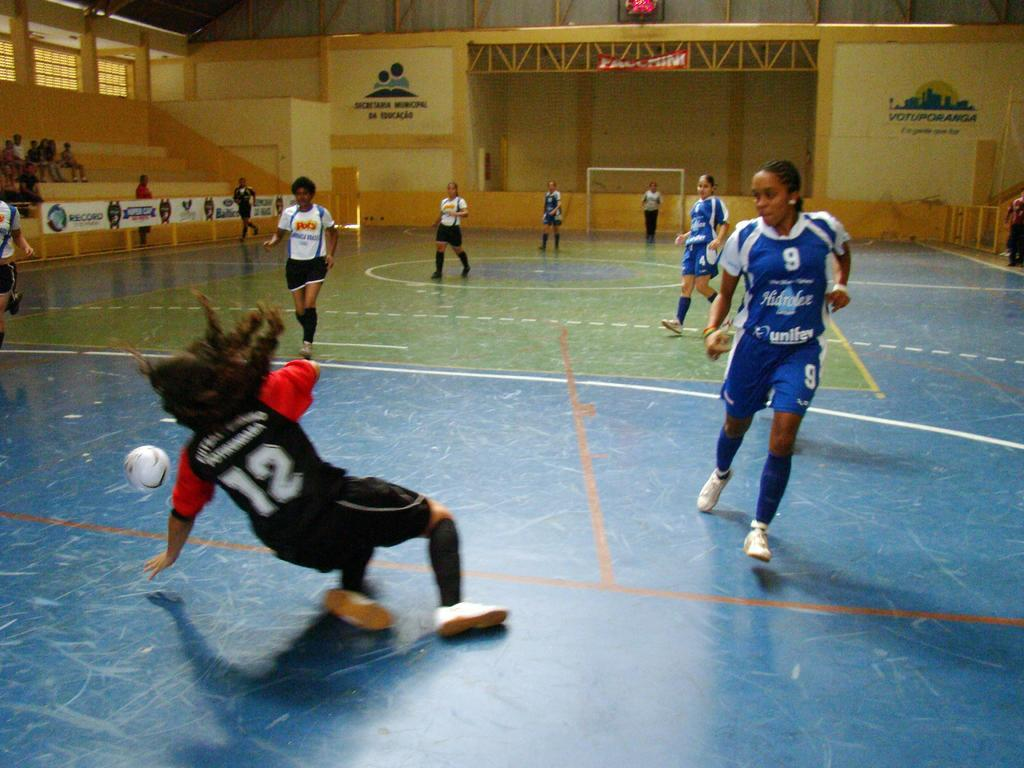Provide a one-sentence caption for the provided image. volleyball players with the numbers 12 and 9 on each of their jerseys. 